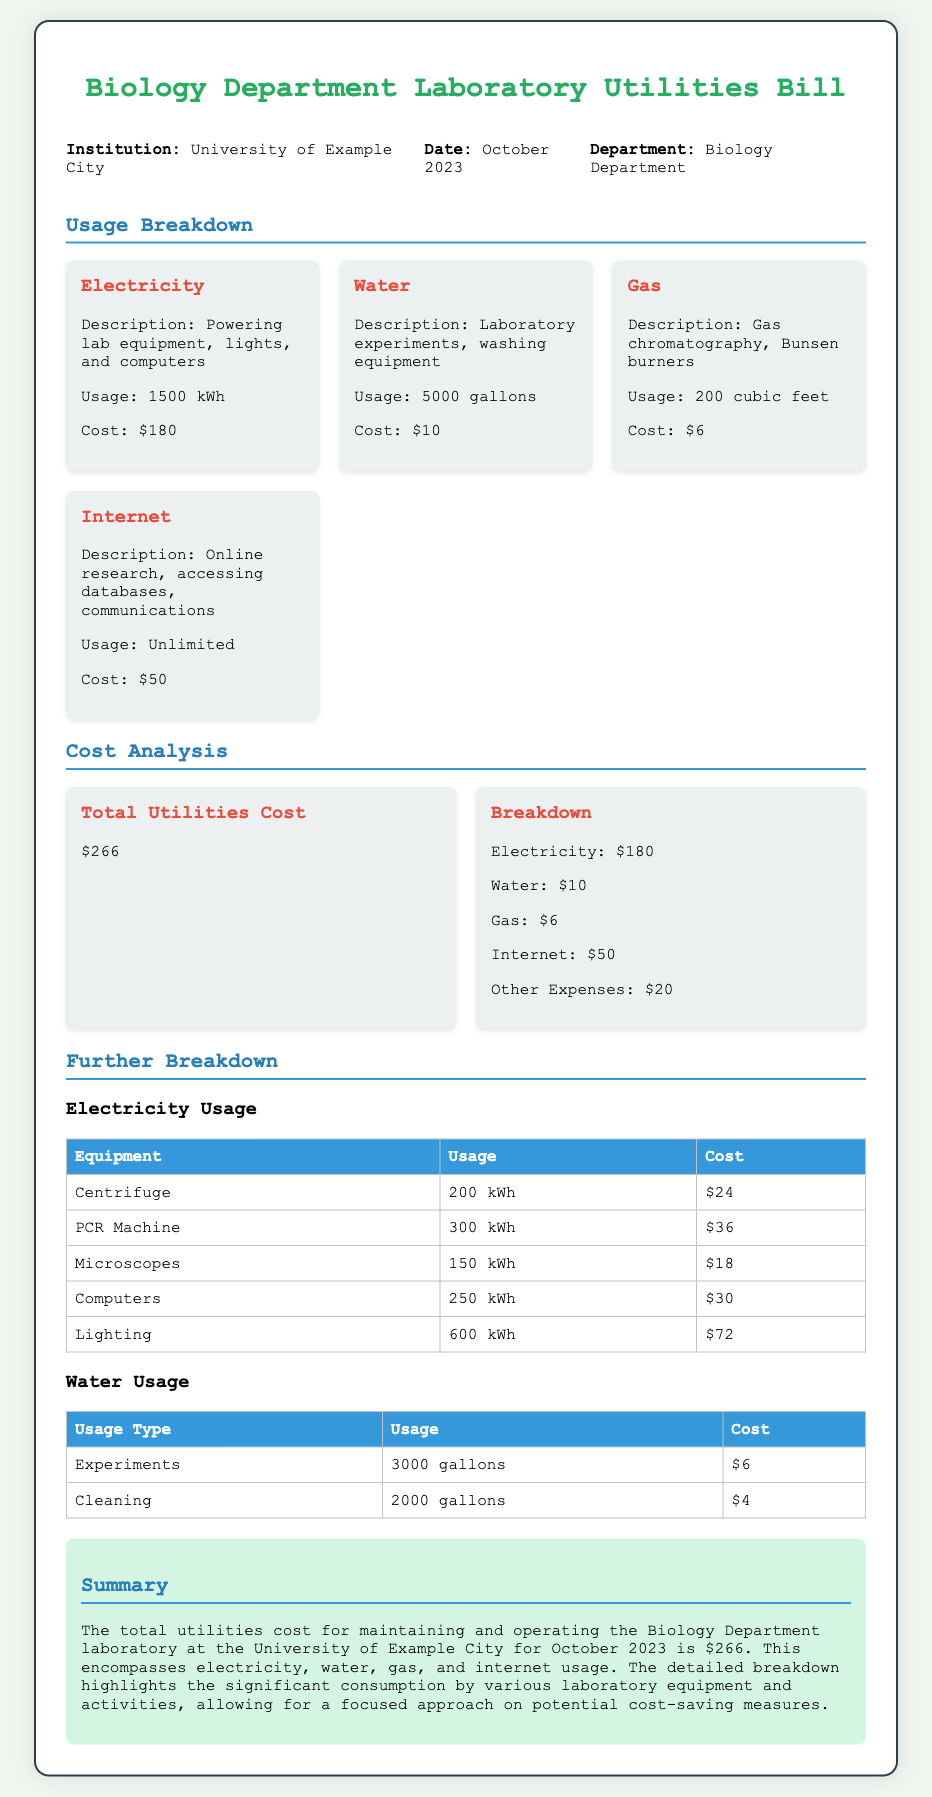What is the total utilities cost? The total utilities cost is mentioned in the document as $266.
Answer: $266 What is the usage of electricity? The document states that the usage of electricity is 1500 kWh.
Answer: 1500 kWh How much did water usage cost? The document specifies that the cost of water usage is $10.
Answer: $10 What equipment used the most electricity? The usage breakdown table shows that the lighting consumed 600 kWh, making it the highest.
Answer: Lighting What was the gas usage in cubic feet? The document indicates that gas usage was 200 cubic feet.
Answer: 200 cubic feet What month and year does this bill represent? The document lists the date as October 2023.
Answer: October 2023 Which institution issued this utilities bill? The document states that the institution is the University of Example City.
Answer: University of Example City What is the purpose of the internet usage listed? The description for internet usage is for online research, accessing databases, and communications.
Answer: Online research, accessing databases, communications How many gallons of water were used for experiments? The document indicates that 3000 gallons were used for experiments.
Answer: 3000 gallons 